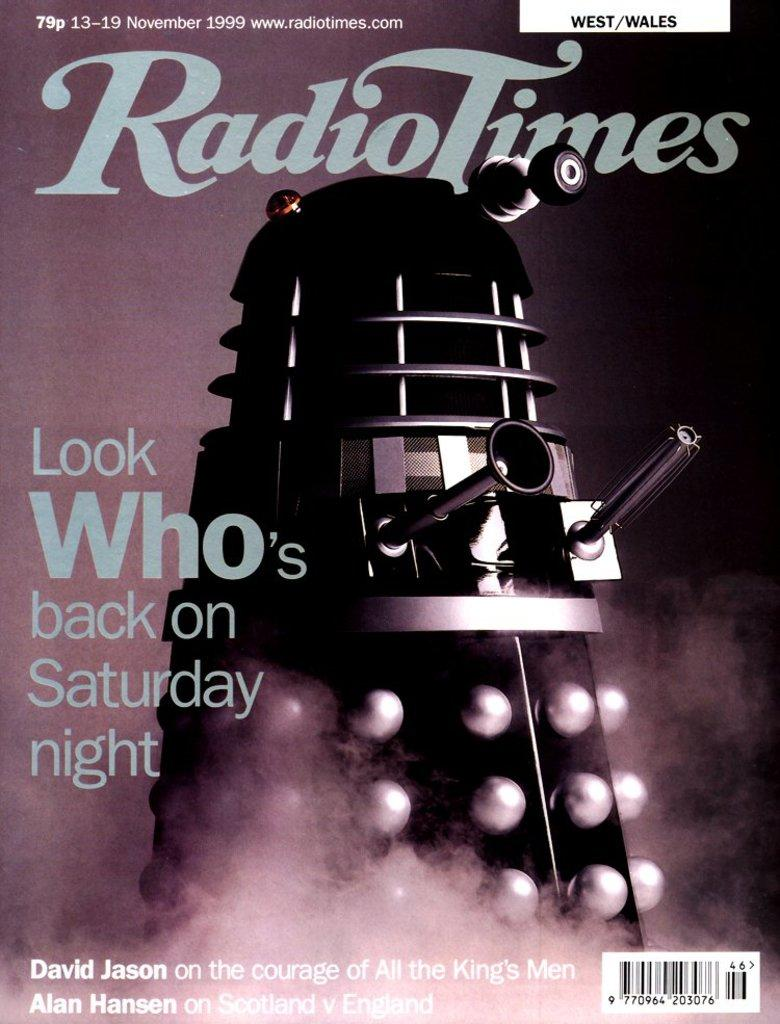Provide a one-sentence caption for the provided image. A magazine cover by the name of Radio Times. 